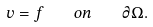Convert formula to latex. <formula><loc_0><loc_0><loc_500><loc_500>v = f \quad o n \quad \partial \Omega .</formula> 